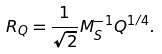<formula> <loc_0><loc_0><loc_500><loc_500>R _ { Q } = \frac { 1 } { \sqrt { 2 } } M _ { S } ^ { - 1 } Q ^ { 1 / 4 } .</formula> 